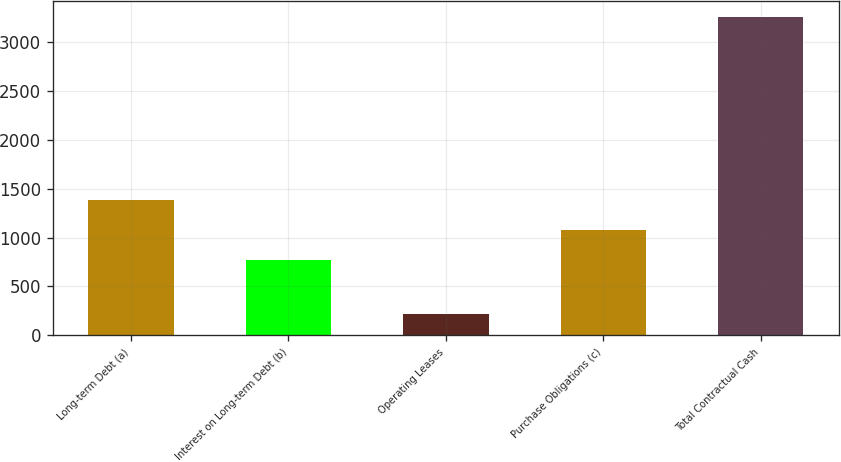<chart> <loc_0><loc_0><loc_500><loc_500><bar_chart><fcel>Long-term Debt (a)<fcel>Interest on Long-term Debt (b)<fcel>Operating Leases<fcel>Purchase Obligations (c)<fcel>Total Contractual Cash<nl><fcel>1382<fcel>774<fcel>217<fcel>1078<fcel>3257<nl></chart> 